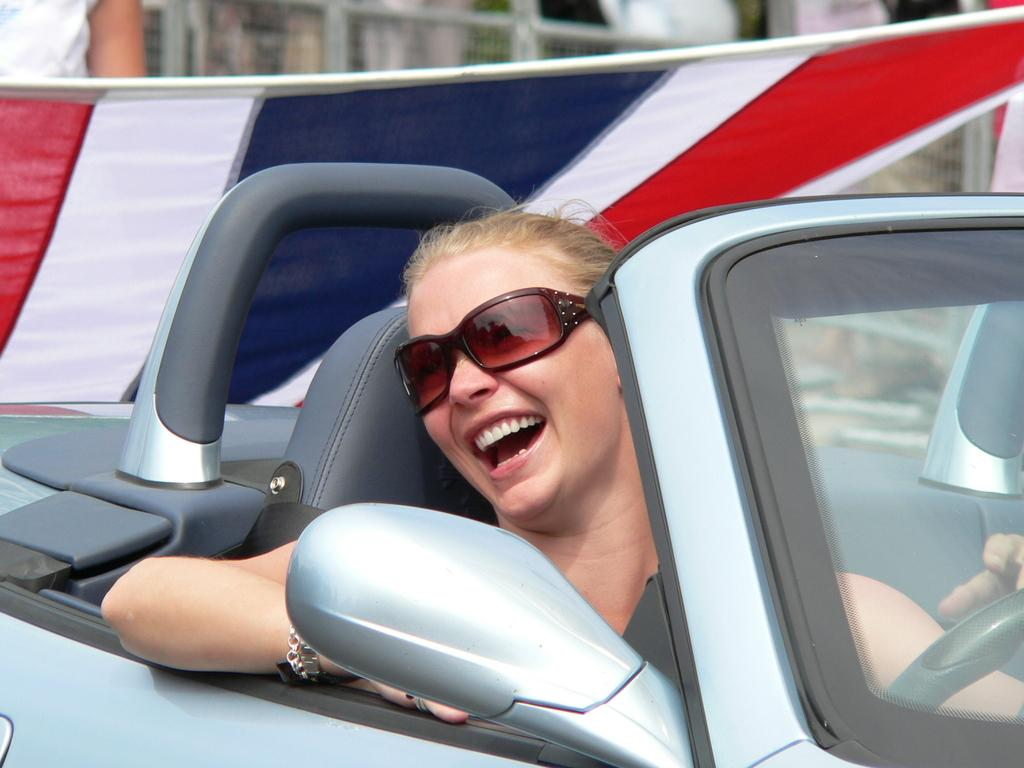Who is the main subject in the image? There is a woman in the image. What is the woman doing in the image? The woman is riding a car. What protective gear is the woman wearing? The woman is wearing goggles. What is the woman's facial expression in the image? The woman is smiling. What can be seen in the background of the image? There is a fencing and a flag in the background of the image. What type of garden can be seen in the image? There is no garden present in the image. What route is the woman taking in the image? The image does not provide information about the route the woman is taking. 